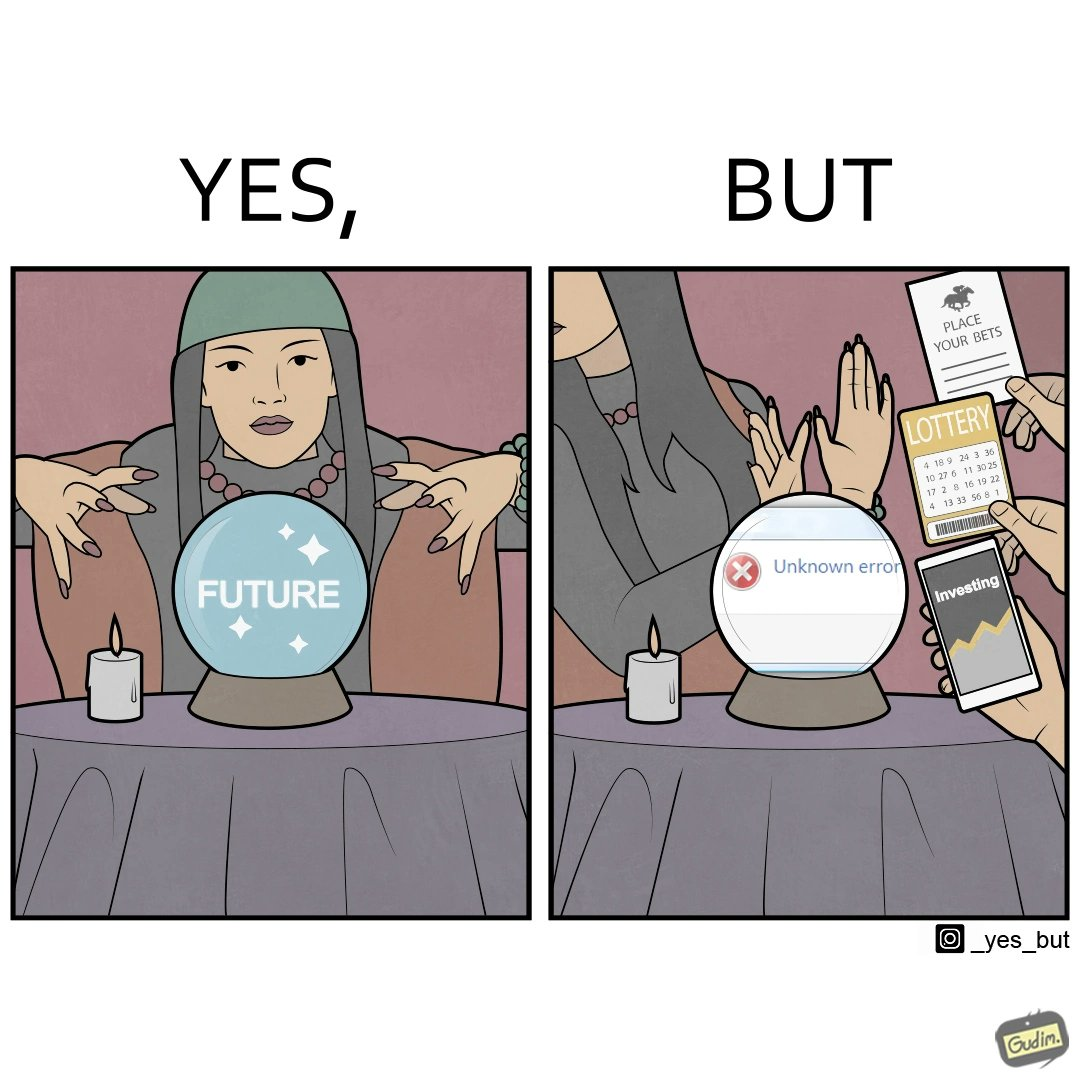Is this a satirical image? Yes, this image is satirical. 